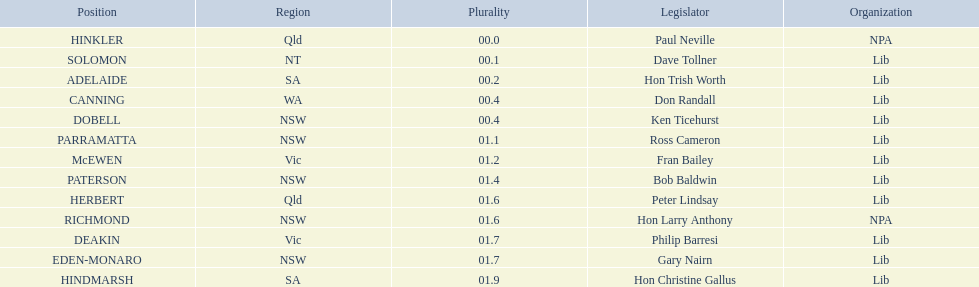Which seats are represented in the electoral system of australia? HINKLER, SOLOMON, ADELAIDE, CANNING, DOBELL, PARRAMATTA, McEWEN, PATERSON, HERBERT, RICHMOND, DEAKIN, EDEN-MONARO, HINDMARSH. What were their majority numbers of both hindmarsh and hinkler? HINKLER, HINDMARSH. Of those two seats, what is the difference in voting majority? 01.9. 